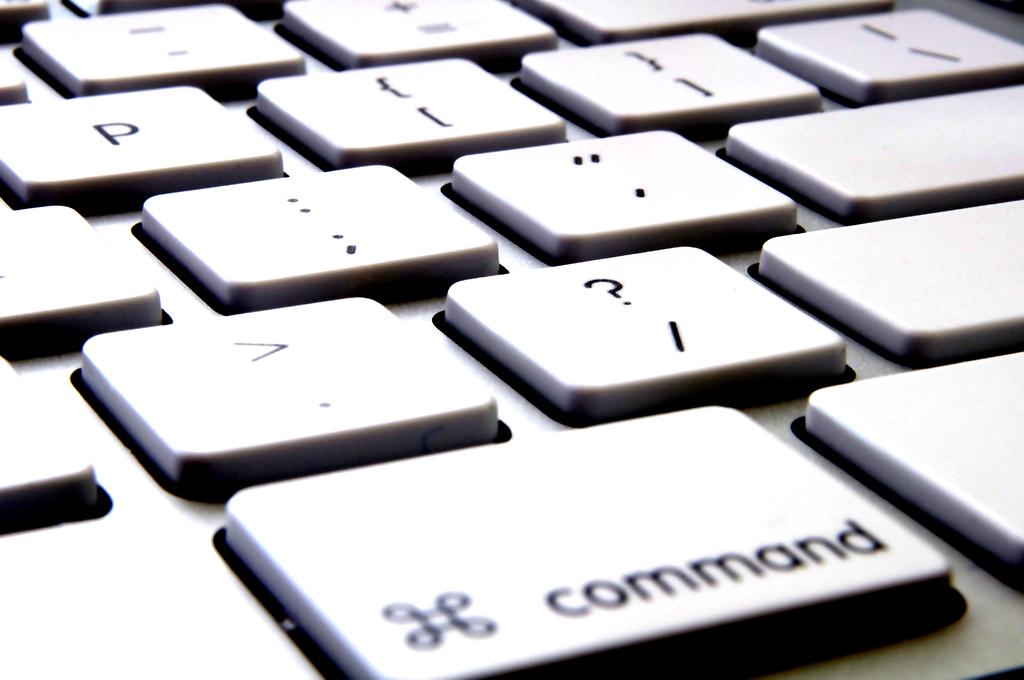What key is shown?
Give a very brief answer. Command. What letter is at the top left?
Provide a succinct answer. P. 